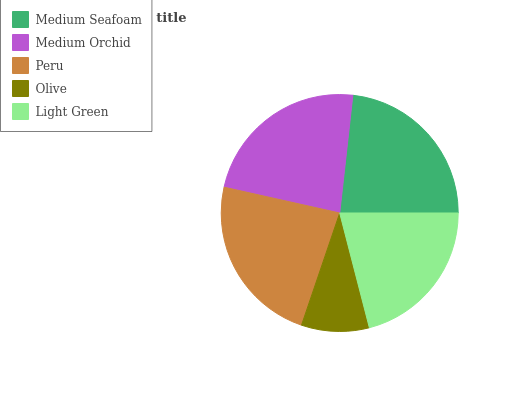Is Olive the minimum?
Answer yes or no. Yes. Is Medium Orchid the maximum?
Answer yes or no. Yes. Is Peru the minimum?
Answer yes or no. No. Is Peru the maximum?
Answer yes or no. No. Is Medium Orchid greater than Peru?
Answer yes or no. Yes. Is Peru less than Medium Orchid?
Answer yes or no. Yes. Is Peru greater than Medium Orchid?
Answer yes or no. No. Is Medium Orchid less than Peru?
Answer yes or no. No. Is Medium Seafoam the high median?
Answer yes or no. Yes. Is Medium Seafoam the low median?
Answer yes or no. Yes. Is Olive the high median?
Answer yes or no. No. Is Olive the low median?
Answer yes or no. No. 